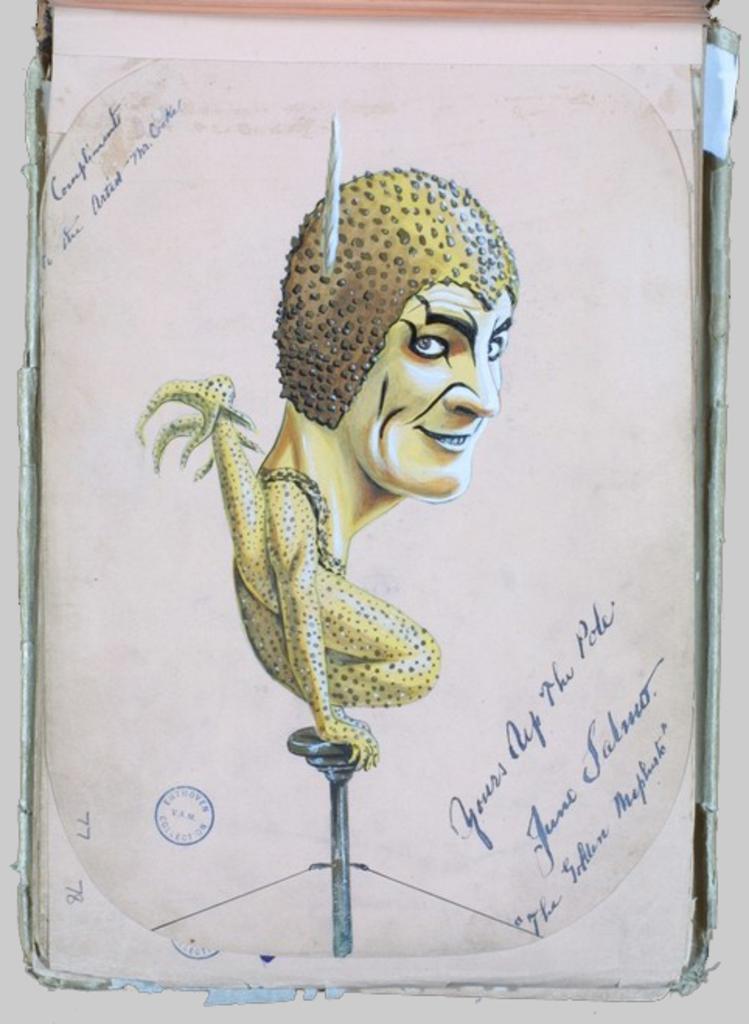Can you describe this image briefly? In the picture we can see a card on it we can see a image of a cartoon and some information on it and with a stamp near it. 